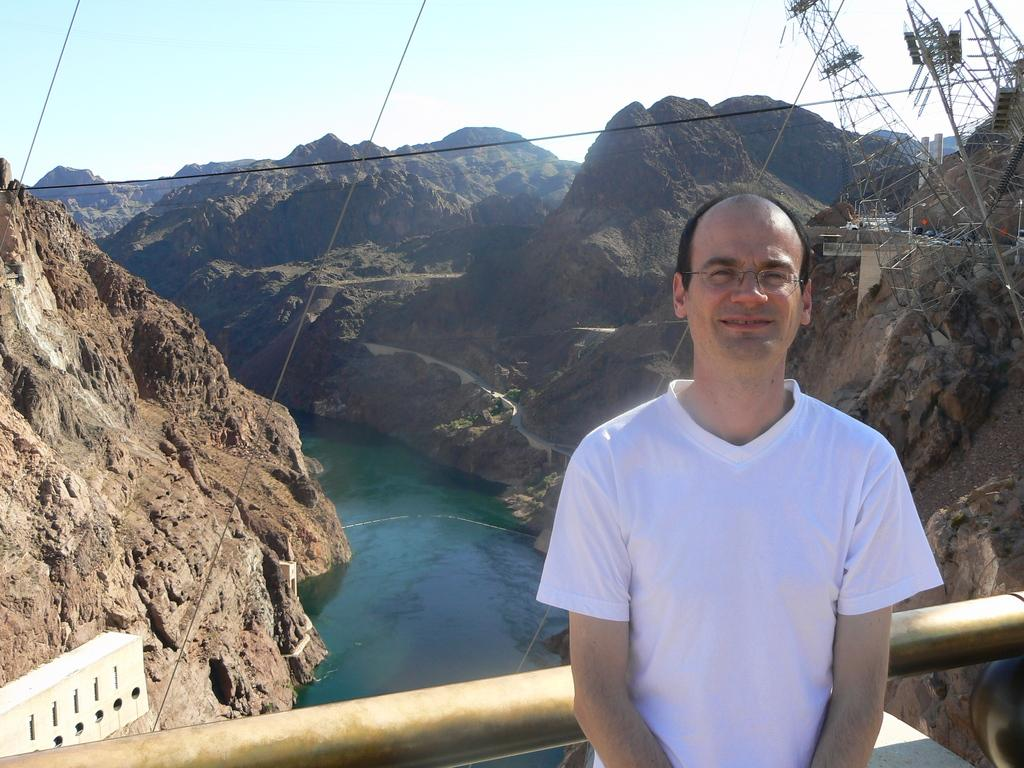What is the main subject of the image? There is a man standing in the image. What is the man wearing? The man is wearing a white t-shirt. What can be seen in the background of the image? There are mountains and a river in the background of the image. What is visible at the top of the image? The sky is visible at the top of the image. Can you tell me how many apples are in the man's hand in the image? There are no apples present in the image; the man is not holding any apples. What type of patch is sewn onto the man's t-shirt in the image? There is no patch visible on the man's t-shirt in the image. 